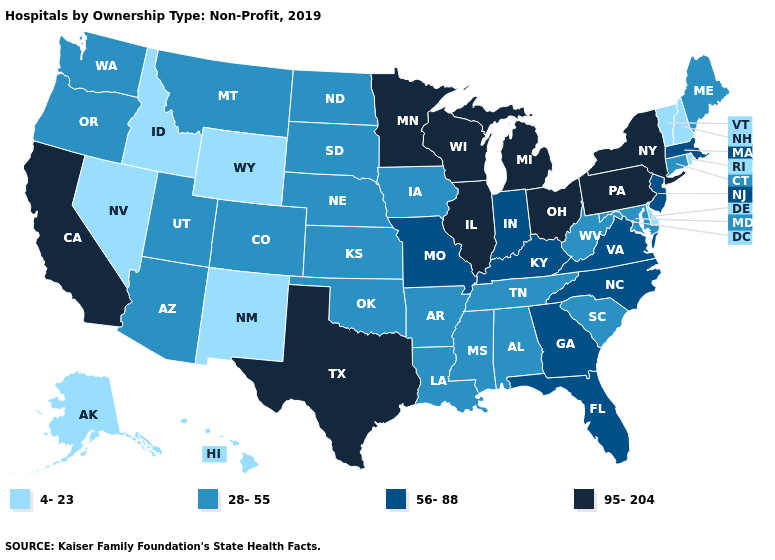What is the lowest value in the USA?
Write a very short answer. 4-23. What is the value of New York?
Short answer required. 95-204. What is the lowest value in the Northeast?
Quick response, please. 4-23. Name the states that have a value in the range 28-55?
Concise answer only. Alabama, Arizona, Arkansas, Colorado, Connecticut, Iowa, Kansas, Louisiana, Maine, Maryland, Mississippi, Montana, Nebraska, North Dakota, Oklahoma, Oregon, South Carolina, South Dakota, Tennessee, Utah, Washington, West Virginia. What is the value of Missouri?
Concise answer only. 56-88. What is the value of Pennsylvania?
Keep it brief. 95-204. Which states have the lowest value in the USA?
Concise answer only. Alaska, Delaware, Hawaii, Idaho, Nevada, New Hampshire, New Mexico, Rhode Island, Vermont, Wyoming. Does Texas have the highest value in the USA?
Quick response, please. Yes. Among the states that border North Dakota , does South Dakota have the lowest value?
Quick response, please. Yes. Which states have the highest value in the USA?
Be succinct. California, Illinois, Michigan, Minnesota, New York, Ohio, Pennsylvania, Texas, Wisconsin. What is the lowest value in the South?
Concise answer only. 4-23. What is the highest value in the Northeast ?
Write a very short answer. 95-204. Which states have the lowest value in the USA?
Concise answer only. Alaska, Delaware, Hawaii, Idaho, Nevada, New Hampshire, New Mexico, Rhode Island, Vermont, Wyoming. Does California have the highest value in the West?
Give a very brief answer. Yes. Name the states that have a value in the range 56-88?
Answer briefly. Florida, Georgia, Indiana, Kentucky, Massachusetts, Missouri, New Jersey, North Carolina, Virginia. 